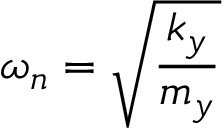<formula> <loc_0><loc_0><loc_500><loc_500>\omega _ { n } = \sqrt { \frac { k _ { y } } { m _ { y } } }</formula> 